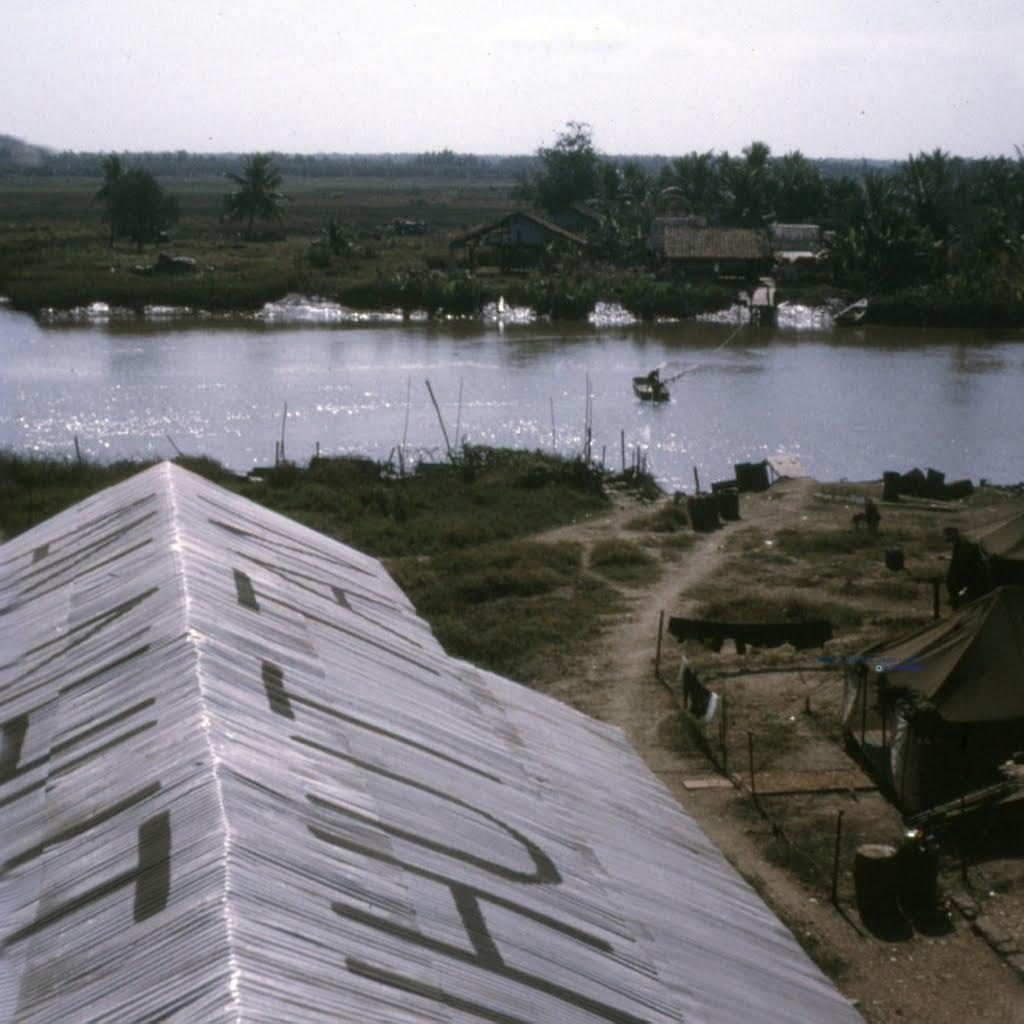Could you give a brief overview of what you see in this image? We can see roof top,tent and clothes and we can see grass. In the background we can see water,trees,houses and sky. 